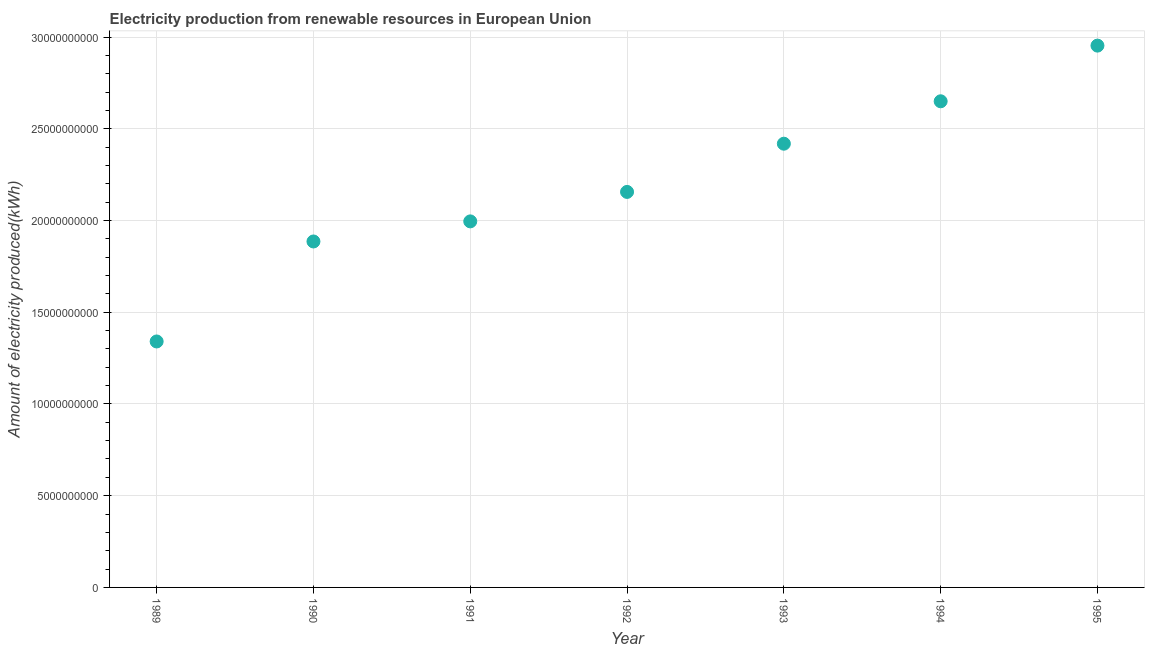What is the amount of electricity produced in 1995?
Provide a succinct answer. 2.95e+1. Across all years, what is the maximum amount of electricity produced?
Provide a short and direct response. 2.95e+1. Across all years, what is the minimum amount of electricity produced?
Ensure brevity in your answer.  1.34e+1. In which year was the amount of electricity produced maximum?
Keep it short and to the point. 1995. What is the sum of the amount of electricity produced?
Provide a short and direct response. 1.54e+11. What is the difference between the amount of electricity produced in 1994 and 1995?
Keep it short and to the point. -3.03e+09. What is the average amount of electricity produced per year?
Your answer should be compact. 2.20e+1. What is the median amount of electricity produced?
Provide a succinct answer. 2.16e+1. Do a majority of the years between 1990 and 1989 (inclusive) have amount of electricity produced greater than 28000000000 kWh?
Your response must be concise. No. What is the ratio of the amount of electricity produced in 1991 to that in 1993?
Offer a terse response. 0.82. Is the amount of electricity produced in 1991 less than that in 1992?
Your response must be concise. Yes. What is the difference between the highest and the second highest amount of electricity produced?
Offer a terse response. 3.03e+09. Is the sum of the amount of electricity produced in 1989 and 1993 greater than the maximum amount of electricity produced across all years?
Give a very brief answer. Yes. What is the difference between the highest and the lowest amount of electricity produced?
Ensure brevity in your answer.  1.61e+1. In how many years, is the amount of electricity produced greater than the average amount of electricity produced taken over all years?
Provide a succinct answer. 3. Does the amount of electricity produced monotonically increase over the years?
Keep it short and to the point. Yes. What is the difference between two consecutive major ticks on the Y-axis?
Provide a succinct answer. 5.00e+09. Does the graph contain grids?
Your answer should be compact. Yes. What is the title of the graph?
Offer a very short reply. Electricity production from renewable resources in European Union. What is the label or title of the Y-axis?
Offer a very short reply. Amount of electricity produced(kWh). What is the Amount of electricity produced(kWh) in 1989?
Your answer should be compact. 1.34e+1. What is the Amount of electricity produced(kWh) in 1990?
Keep it short and to the point. 1.89e+1. What is the Amount of electricity produced(kWh) in 1991?
Your response must be concise. 2.00e+1. What is the Amount of electricity produced(kWh) in 1992?
Make the answer very short. 2.16e+1. What is the Amount of electricity produced(kWh) in 1993?
Offer a very short reply. 2.42e+1. What is the Amount of electricity produced(kWh) in 1994?
Your answer should be compact. 2.65e+1. What is the Amount of electricity produced(kWh) in 1995?
Offer a very short reply. 2.95e+1. What is the difference between the Amount of electricity produced(kWh) in 1989 and 1990?
Offer a very short reply. -5.45e+09. What is the difference between the Amount of electricity produced(kWh) in 1989 and 1991?
Provide a succinct answer. -6.54e+09. What is the difference between the Amount of electricity produced(kWh) in 1989 and 1992?
Provide a succinct answer. -8.15e+09. What is the difference between the Amount of electricity produced(kWh) in 1989 and 1993?
Keep it short and to the point. -1.08e+1. What is the difference between the Amount of electricity produced(kWh) in 1989 and 1994?
Keep it short and to the point. -1.31e+1. What is the difference between the Amount of electricity produced(kWh) in 1989 and 1995?
Ensure brevity in your answer.  -1.61e+1. What is the difference between the Amount of electricity produced(kWh) in 1990 and 1991?
Your answer should be compact. -1.10e+09. What is the difference between the Amount of electricity produced(kWh) in 1990 and 1992?
Offer a very short reply. -2.70e+09. What is the difference between the Amount of electricity produced(kWh) in 1990 and 1993?
Give a very brief answer. -5.33e+09. What is the difference between the Amount of electricity produced(kWh) in 1990 and 1994?
Your answer should be compact. -7.64e+09. What is the difference between the Amount of electricity produced(kWh) in 1990 and 1995?
Your answer should be compact. -1.07e+1. What is the difference between the Amount of electricity produced(kWh) in 1991 and 1992?
Your answer should be compact. -1.61e+09. What is the difference between the Amount of electricity produced(kWh) in 1991 and 1993?
Provide a succinct answer. -4.23e+09. What is the difference between the Amount of electricity produced(kWh) in 1991 and 1994?
Your response must be concise. -6.55e+09. What is the difference between the Amount of electricity produced(kWh) in 1991 and 1995?
Your answer should be compact. -9.58e+09. What is the difference between the Amount of electricity produced(kWh) in 1992 and 1993?
Give a very brief answer. -2.63e+09. What is the difference between the Amount of electricity produced(kWh) in 1992 and 1994?
Give a very brief answer. -4.94e+09. What is the difference between the Amount of electricity produced(kWh) in 1992 and 1995?
Make the answer very short. -7.97e+09. What is the difference between the Amount of electricity produced(kWh) in 1993 and 1994?
Your response must be concise. -2.31e+09. What is the difference between the Amount of electricity produced(kWh) in 1993 and 1995?
Your answer should be very brief. -5.35e+09. What is the difference between the Amount of electricity produced(kWh) in 1994 and 1995?
Make the answer very short. -3.03e+09. What is the ratio of the Amount of electricity produced(kWh) in 1989 to that in 1990?
Offer a very short reply. 0.71. What is the ratio of the Amount of electricity produced(kWh) in 1989 to that in 1991?
Provide a short and direct response. 0.67. What is the ratio of the Amount of electricity produced(kWh) in 1989 to that in 1992?
Make the answer very short. 0.62. What is the ratio of the Amount of electricity produced(kWh) in 1989 to that in 1993?
Keep it short and to the point. 0.55. What is the ratio of the Amount of electricity produced(kWh) in 1989 to that in 1994?
Provide a succinct answer. 0.51. What is the ratio of the Amount of electricity produced(kWh) in 1989 to that in 1995?
Your answer should be compact. 0.45. What is the ratio of the Amount of electricity produced(kWh) in 1990 to that in 1991?
Provide a succinct answer. 0.94. What is the ratio of the Amount of electricity produced(kWh) in 1990 to that in 1993?
Offer a very short reply. 0.78. What is the ratio of the Amount of electricity produced(kWh) in 1990 to that in 1994?
Provide a succinct answer. 0.71. What is the ratio of the Amount of electricity produced(kWh) in 1990 to that in 1995?
Provide a succinct answer. 0.64. What is the ratio of the Amount of electricity produced(kWh) in 1991 to that in 1992?
Provide a succinct answer. 0.93. What is the ratio of the Amount of electricity produced(kWh) in 1991 to that in 1993?
Your response must be concise. 0.82. What is the ratio of the Amount of electricity produced(kWh) in 1991 to that in 1994?
Provide a succinct answer. 0.75. What is the ratio of the Amount of electricity produced(kWh) in 1991 to that in 1995?
Provide a succinct answer. 0.68. What is the ratio of the Amount of electricity produced(kWh) in 1992 to that in 1993?
Ensure brevity in your answer.  0.89. What is the ratio of the Amount of electricity produced(kWh) in 1992 to that in 1994?
Offer a terse response. 0.81. What is the ratio of the Amount of electricity produced(kWh) in 1992 to that in 1995?
Offer a very short reply. 0.73. What is the ratio of the Amount of electricity produced(kWh) in 1993 to that in 1995?
Your answer should be very brief. 0.82. What is the ratio of the Amount of electricity produced(kWh) in 1994 to that in 1995?
Keep it short and to the point. 0.9. 